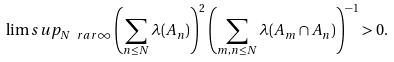Convert formula to latex. <formula><loc_0><loc_0><loc_500><loc_500>\lim s u p _ { N \ r a r \infty } \left ( \sum _ { n \leq N } \lambda ( A _ { n } ) \right ) ^ { 2 } \left ( \sum _ { m , n \leq N } \lambda ( A _ { m } \cap A _ { n } ) \right ) ^ { - 1 } > 0 .</formula> 